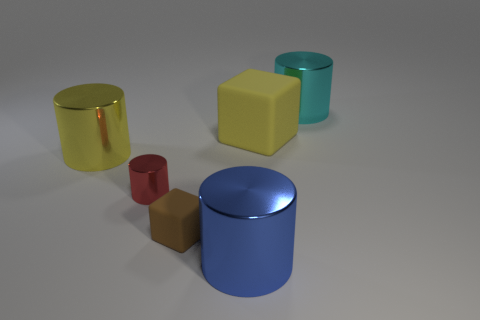Subtract 1 cylinders. How many cylinders are left? 3 Add 2 small brown matte blocks. How many objects exist? 8 Subtract all purple cylinders. Subtract all gray blocks. How many cylinders are left? 4 Subtract all blocks. How many objects are left? 4 Add 1 cyan metallic cylinders. How many cyan metallic cylinders are left? 2 Add 1 big yellow matte objects. How many big yellow matte objects exist? 2 Subtract 1 yellow blocks. How many objects are left? 5 Subtract all blue metallic blocks. Subtract all large yellow matte blocks. How many objects are left? 5 